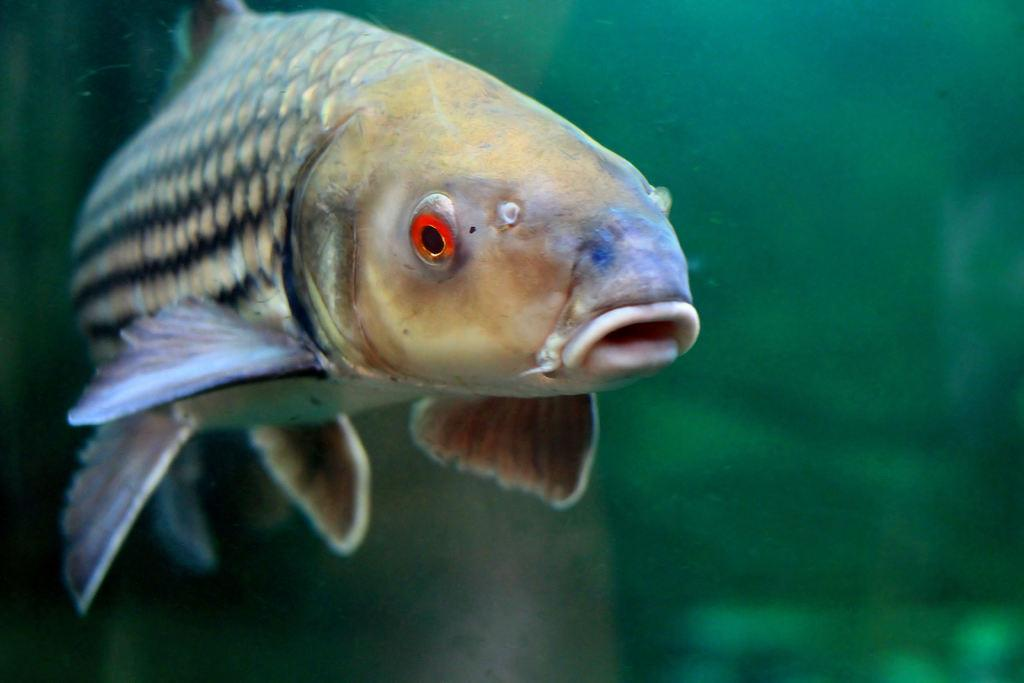What type of animal is in the image? There is a fish in the image. Where is the fish located? The fish is in the water. What type of humor can be seen in the image? There is no humor present in the image; it features a fish in the water. What news event is depicted in the image? There is no news event depicted in the image; it features a fish in the water. 